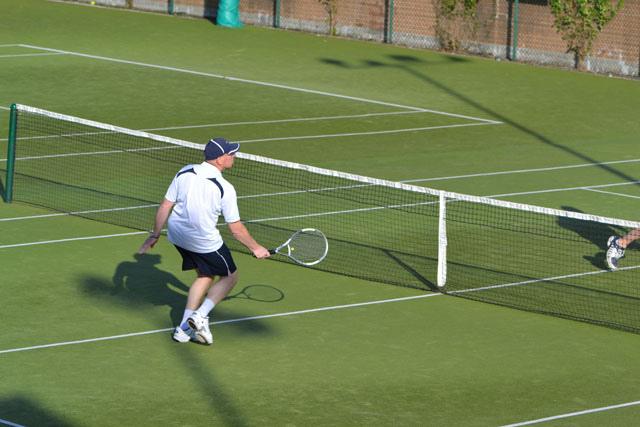How many courts can be seen?
Short answer required. 2. What sport is this?
Be succinct. Tennis. Is this a professional tennis match?
Quick response, please. No. Is this a woman's competition?
Short answer required. No. 